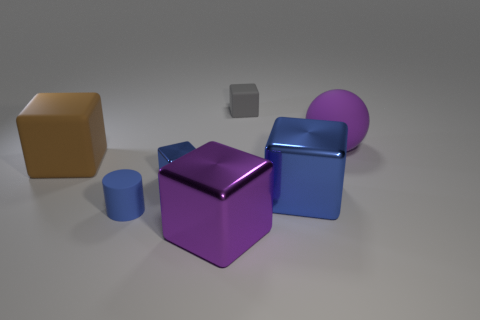Subtract all gray cubes. How many cubes are left? 4 Subtract all large purple shiny cubes. How many cubes are left? 4 Subtract all red cubes. Subtract all blue balls. How many cubes are left? 5 Add 3 big balls. How many objects exist? 10 Subtract all spheres. How many objects are left? 6 Subtract all rubber blocks. Subtract all shiny balls. How many objects are left? 5 Add 6 big brown cubes. How many big brown cubes are left? 7 Add 4 cyan blocks. How many cyan blocks exist? 4 Subtract 0 red blocks. How many objects are left? 7 